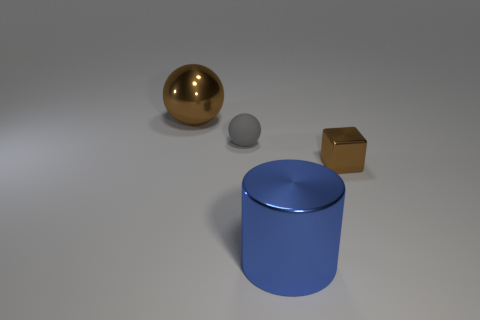How many spheres are the same size as the shiny block?
Provide a short and direct response. 1. Are there fewer big objects in front of the shiny cylinder than tiny things in front of the gray thing?
Provide a short and direct response. Yes. What size is the brown thing that is left of the big object that is in front of the brown metallic object that is to the left of the small metallic thing?
Your answer should be compact. Large. There is a thing that is in front of the small gray ball and to the left of the tiny metal thing; what is its size?
Give a very brief answer. Large. What is the shape of the large shiny thing behind the brown metallic object to the right of the blue cylinder?
Offer a very short reply. Sphere. Is there any other thing of the same color as the cube?
Give a very brief answer. Yes. What is the shape of the large thing to the right of the large brown metal sphere?
Give a very brief answer. Cylinder. What is the shape of the thing that is right of the small sphere and behind the large cylinder?
Your answer should be very brief. Cube. What number of blue objects are either metallic cylinders or balls?
Provide a succinct answer. 1. There is a big thing that is left of the rubber object; is it the same color as the rubber object?
Make the answer very short. No. 